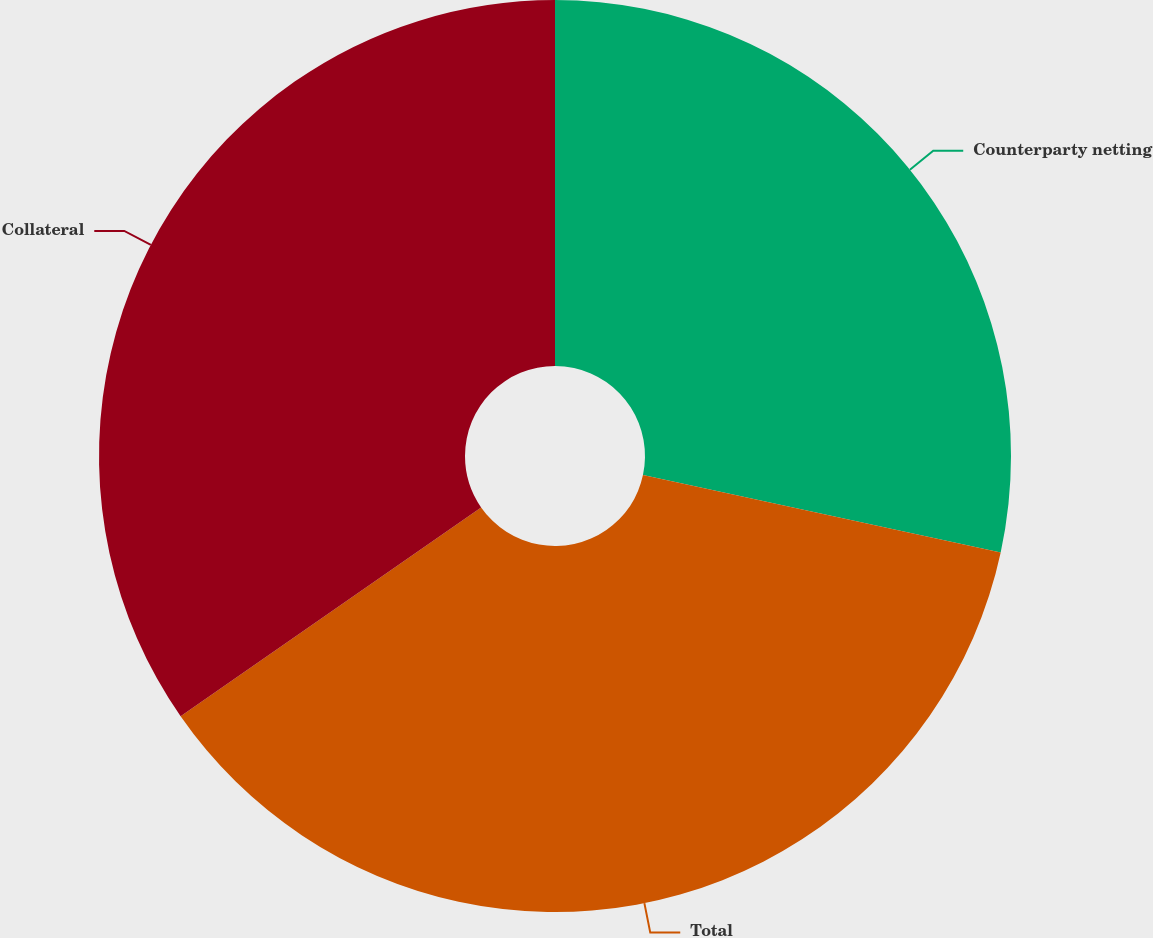<chart> <loc_0><loc_0><loc_500><loc_500><pie_chart><fcel>Counterparty netting<fcel>Total<fcel>Collateral<nl><fcel>28.39%<fcel>36.94%<fcel>34.67%<nl></chart> 